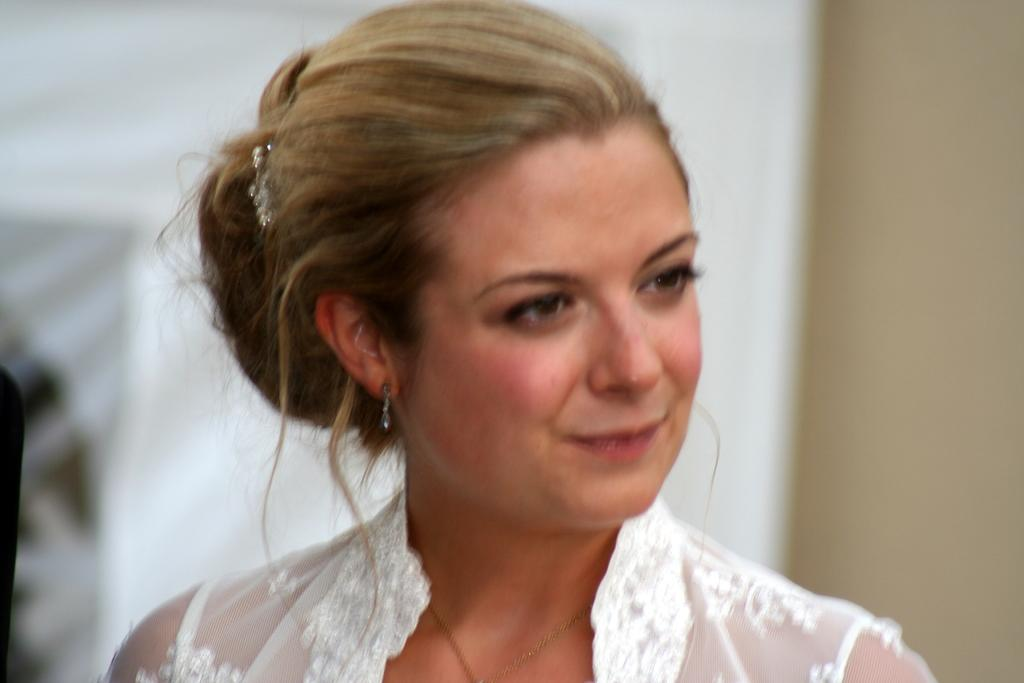Who is the main subject in the image? There is a woman in the image. What can be seen in the background of the image? The background of the image is white. What is the income of the woman in the image? There is no information about the woman's income in the image. 